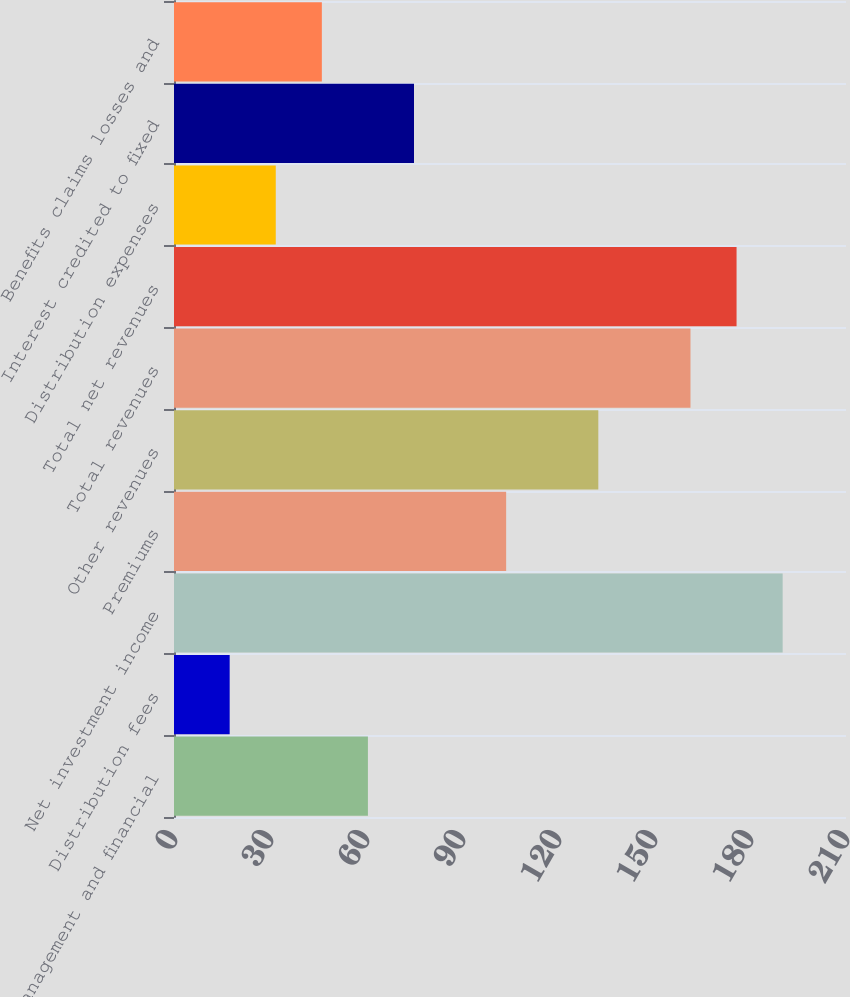Convert chart to OTSL. <chart><loc_0><loc_0><loc_500><loc_500><bar_chart><fcel>Management and financial<fcel>Distribution fees<fcel>Net investment income<fcel>Premiums<fcel>Other revenues<fcel>Total revenues<fcel>Total net revenues<fcel>Distribution expenses<fcel>Interest credited to fixed<fcel>Benefits claims losses and<nl><fcel>60.6<fcel>17.4<fcel>190.2<fcel>103.8<fcel>132.6<fcel>161.4<fcel>175.8<fcel>31.8<fcel>75<fcel>46.2<nl></chart> 